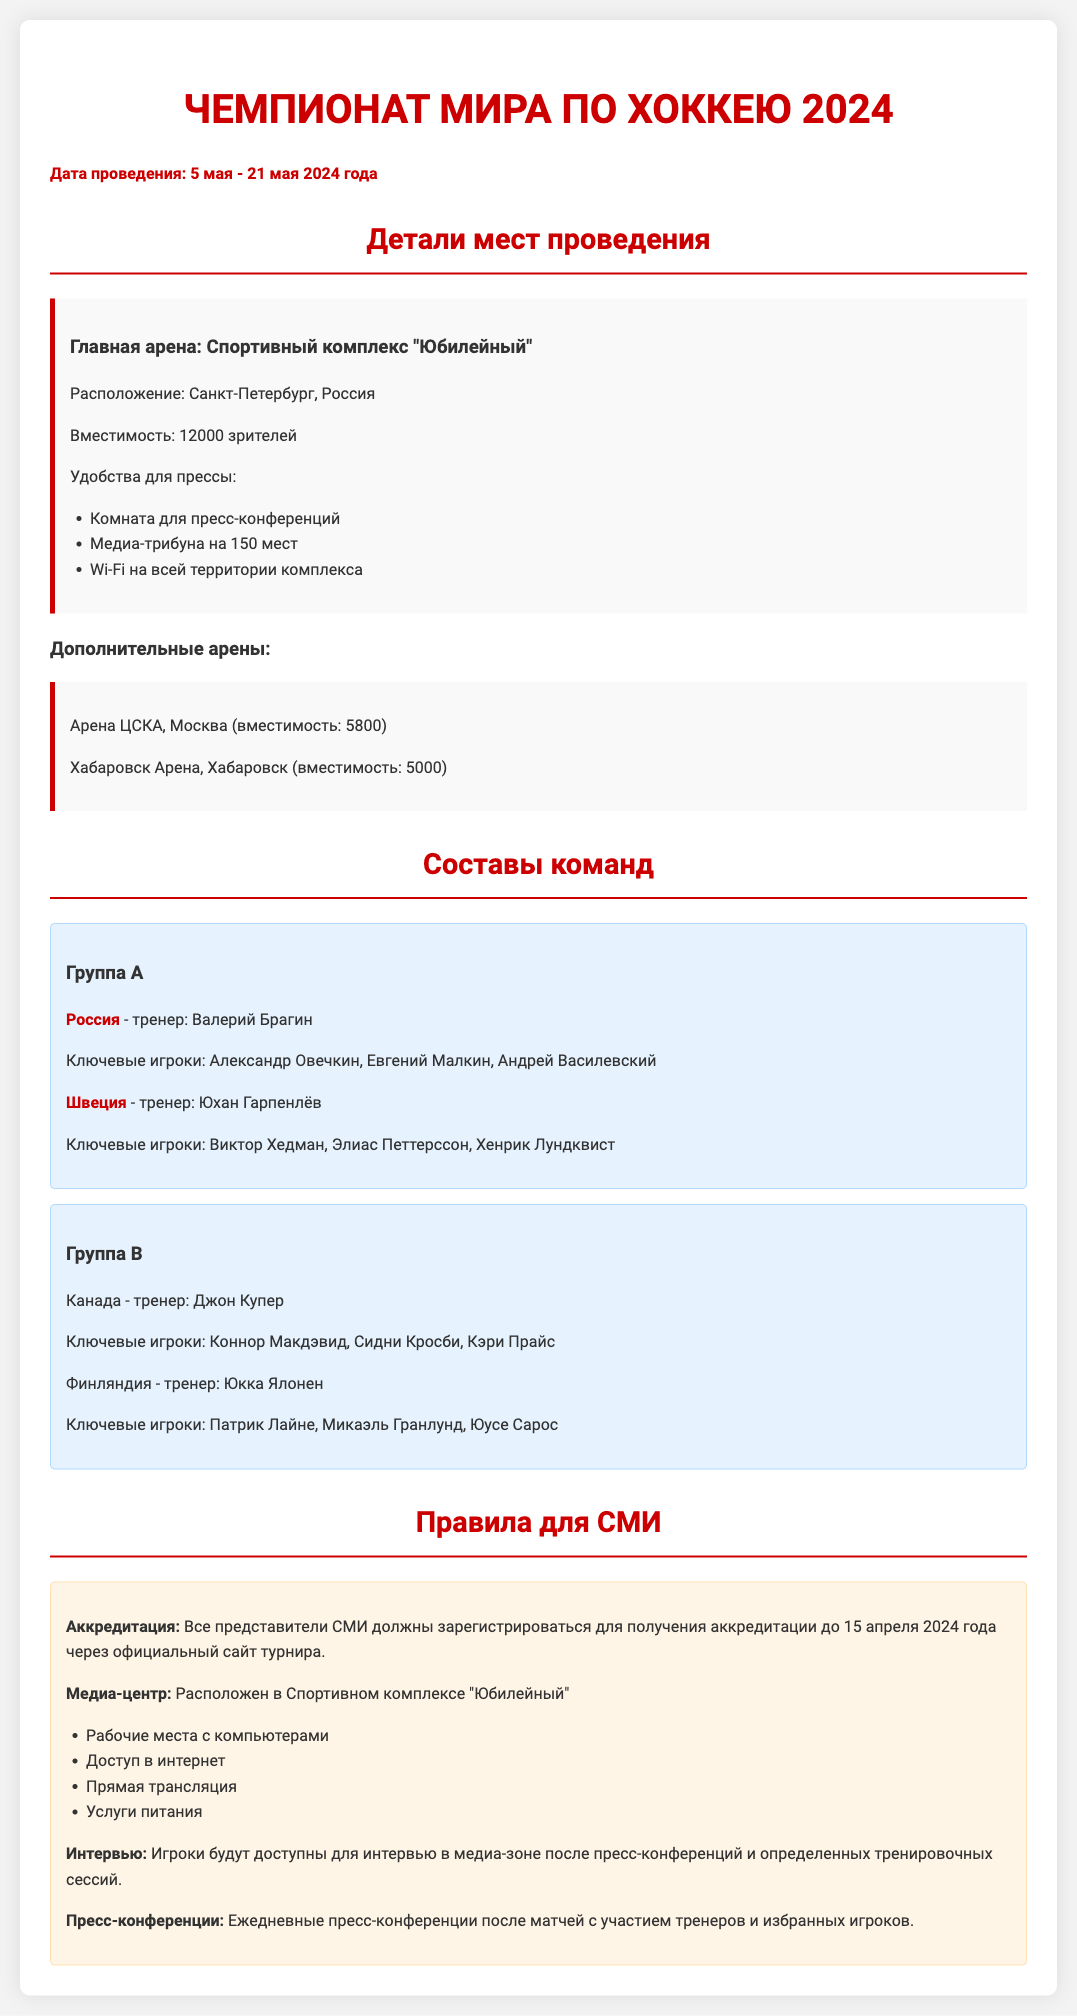Каковы даты проведения турнира? Даты проведения указаны в начале документа, с 5 по 21 мая 2024 года.
Answer: 5 мая - 21 мая 2024 года Какова вместимость главной арены? Вместимость главной арены "Юбилейный" упомянута в разделе деталей мест проведения.
Answer: 12000 зрителей Какие ключевые игроки у России? Ключевые игроки для команды России перечислены в разделе о составах команд.
Answer: Александр Овечкин, Евгений Малкин, Андрей Василевский Какую арена используется в Хабаровске? Используемая арена в Хабаровске указана в разделе дополнительных арен.
Answer: Хабаровск Арена Какой срок аккредитации для представителей СМИ? Срок аккредитации указан в правилах для СМИ, последняя дата.
Answer: 15 апреля 2024 года Каковы удобства для прессы на главной арене? Удобства перечислены в разделе про главную арену, включая список.
Answer: Комната для пресс-конференций, медиа-трибуна на 150 мест, Wi-Fi Сколько команд в Группе А? Количество команд в Группе А можно узнать из состава команды.
Answer: 2 команды Какова роль тренеров в этом турнире? Роль тренеров указана в составе команд, они ведут команды.
Answer: Тренеры ведущие команды 